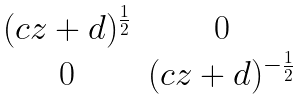<formula> <loc_0><loc_0><loc_500><loc_500>\begin{matrix} ( c z + d ) ^ { \frac { 1 } { 2 } } & 0 \\ 0 & ( c z + d ) ^ { - \frac { 1 } { 2 } } \end{matrix}</formula> 